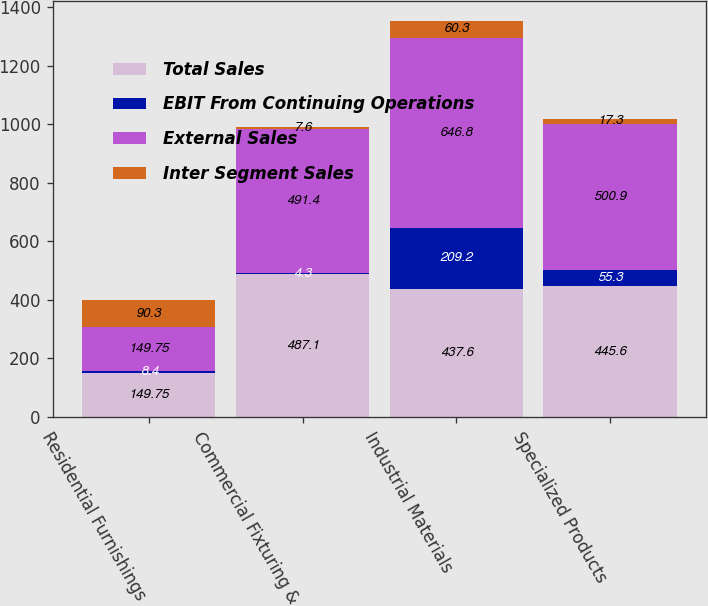Convert chart to OTSL. <chart><loc_0><loc_0><loc_500><loc_500><stacked_bar_chart><ecel><fcel>Residential Furnishings<fcel>Commercial Fixturing &<fcel>Industrial Materials<fcel>Specialized Products<nl><fcel>Total Sales<fcel>149.75<fcel>487.1<fcel>437.6<fcel>445.6<nl><fcel>EBIT From Continuing Operations<fcel>8.4<fcel>4.3<fcel>209.2<fcel>55.3<nl><fcel>External Sales<fcel>149.75<fcel>491.4<fcel>646.8<fcel>500.9<nl><fcel>Inter Segment Sales<fcel>90.3<fcel>7.6<fcel>60.3<fcel>17.3<nl></chart> 